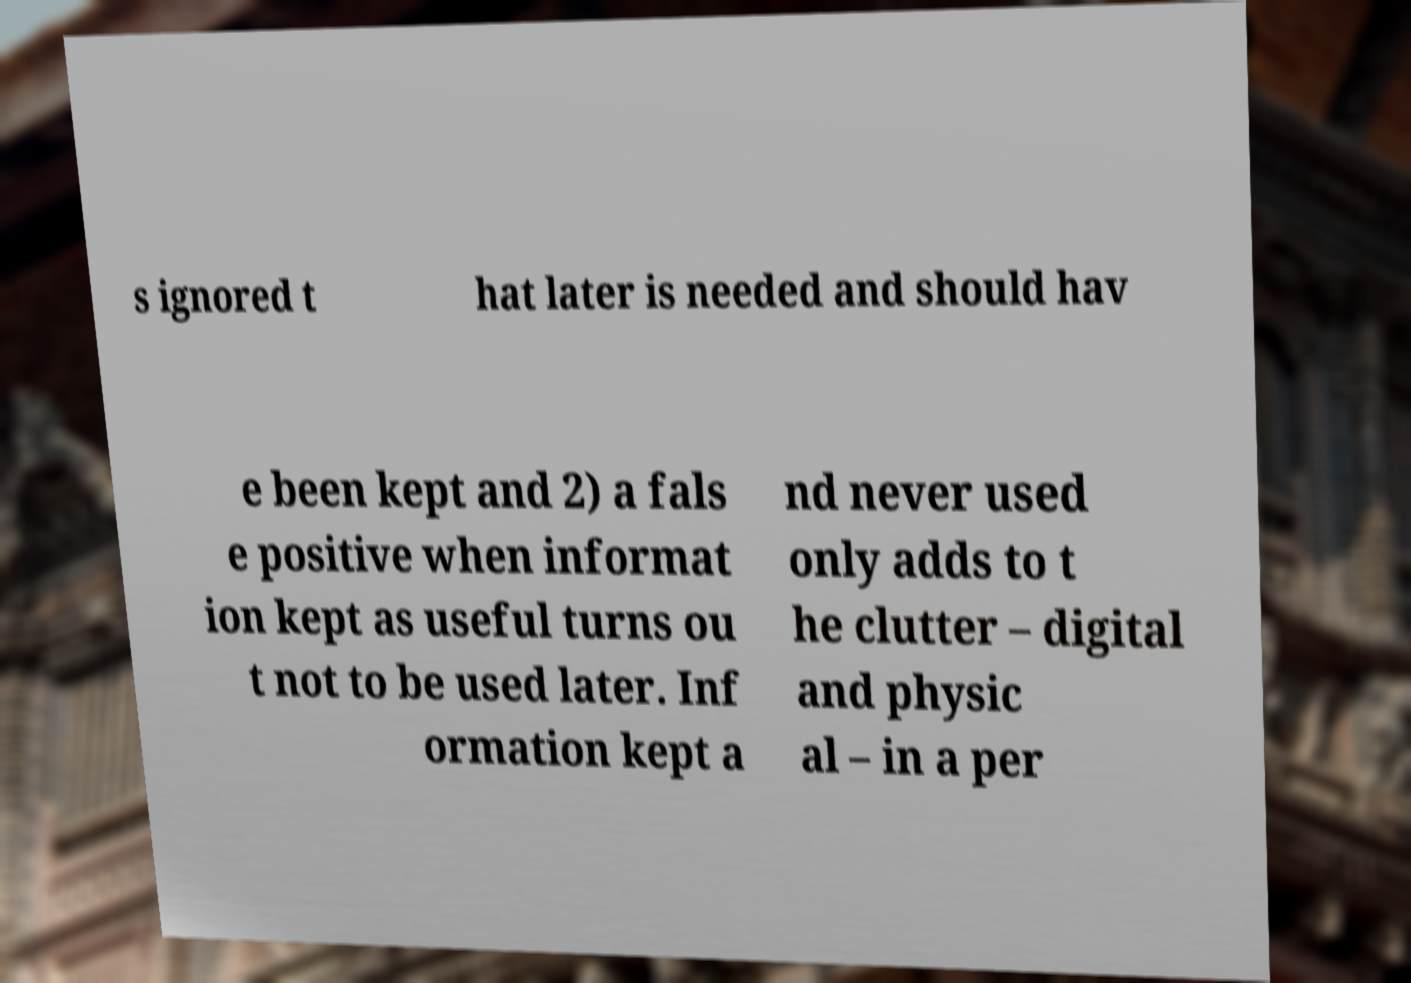There's text embedded in this image that I need extracted. Can you transcribe it verbatim? s ignored t hat later is needed and should hav e been kept and 2) a fals e positive when informat ion kept as useful turns ou t not to be used later. Inf ormation kept a nd never used only adds to t he clutter – digital and physic al – in a per 